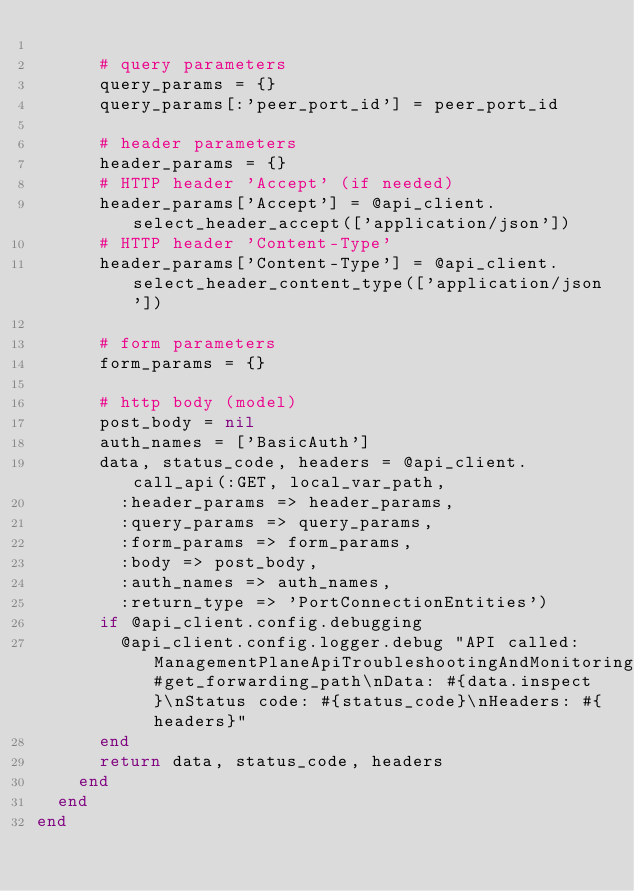Convert code to text. <code><loc_0><loc_0><loc_500><loc_500><_Ruby_>
      # query parameters
      query_params = {}
      query_params[:'peer_port_id'] = peer_port_id

      # header parameters
      header_params = {}
      # HTTP header 'Accept' (if needed)
      header_params['Accept'] = @api_client.select_header_accept(['application/json'])
      # HTTP header 'Content-Type'
      header_params['Content-Type'] = @api_client.select_header_content_type(['application/json'])

      # form parameters
      form_params = {}

      # http body (model)
      post_body = nil
      auth_names = ['BasicAuth']
      data, status_code, headers = @api_client.call_api(:GET, local_var_path,
        :header_params => header_params,
        :query_params => query_params,
        :form_params => form_params,
        :body => post_body,
        :auth_names => auth_names,
        :return_type => 'PortConnectionEntities')
      if @api_client.config.debugging
        @api_client.config.logger.debug "API called: ManagementPlaneApiTroubleshootingAndMonitoringPortConnectionApi#get_forwarding_path\nData: #{data.inspect}\nStatus code: #{status_code}\nHeaders: #{headers}"
      end
      return data, status_code, headers
    end
  end
end
</code> 